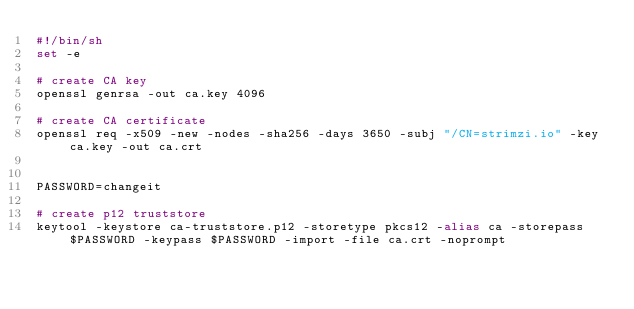<code> <loc_0><loc_0><loc_500><loc_500><_Bash_>#!/bin/sh
set -e

# create CA key
openssl genrsa -out ca.key 4096

# create CA certificate
openssl req -x509 -new -nodes -sha256 -days 3650 -subj "/CN=strimzi.io" -key ca.key -out ca.crt


PASSWORD=changeit

# create p12 truststore
keytool -keystore ca-truststore.p12 -storetype pkcs12 -alias ca -storepass $PASSWORD -keypass $PASSWORD -import -file ca.crt -noprompt
</code> 